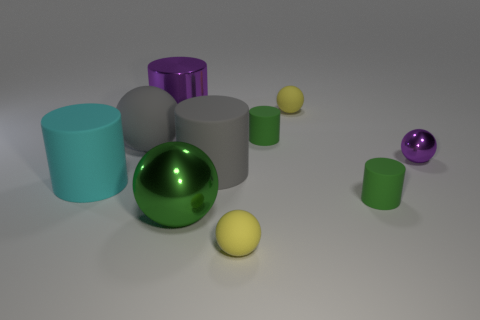What materials are the objects in the image likely made from? The objects in the image have a smooth, reflective surface, suggesting they could be made of polished metal or plastic with a high-gloss finish. This gives them a synthetic and manufactured appearance. 